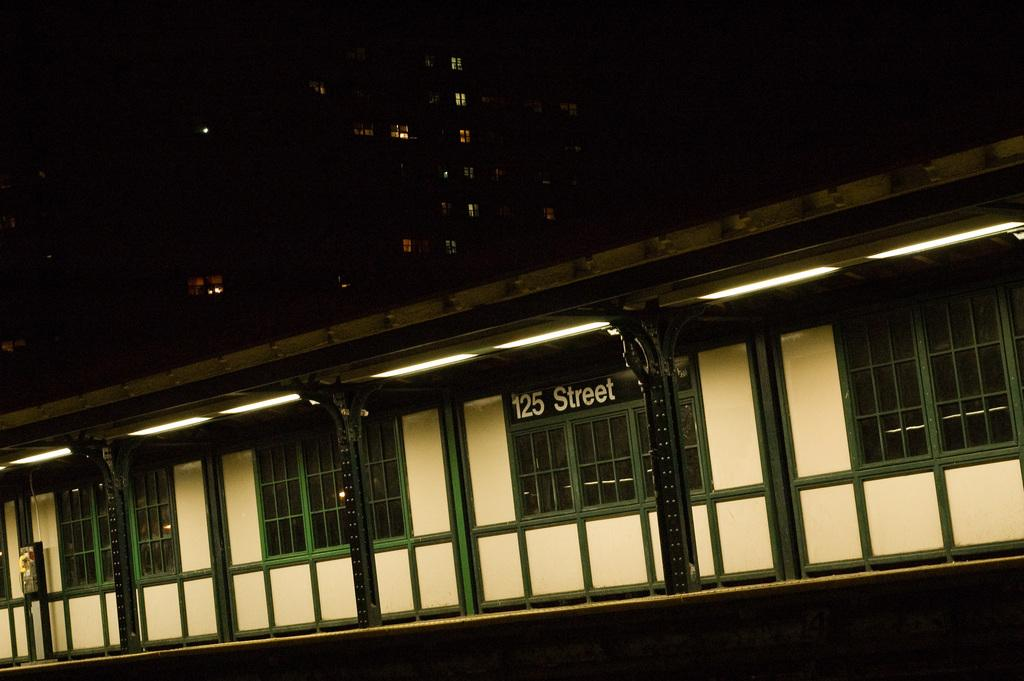What type of structures can be seen in the image? There are buildings in the image. What feature is visible on the buildings? There are windows visible in the image. What else can be seen on the buildings? There are lights visible in the image. What type of small structure is present in the image? There is a shed in the image. What additional information is present in the image? There is some text and number present in the image. What type of cheese is being held by the hands in the image? There are no hands or cheese present in the image. 